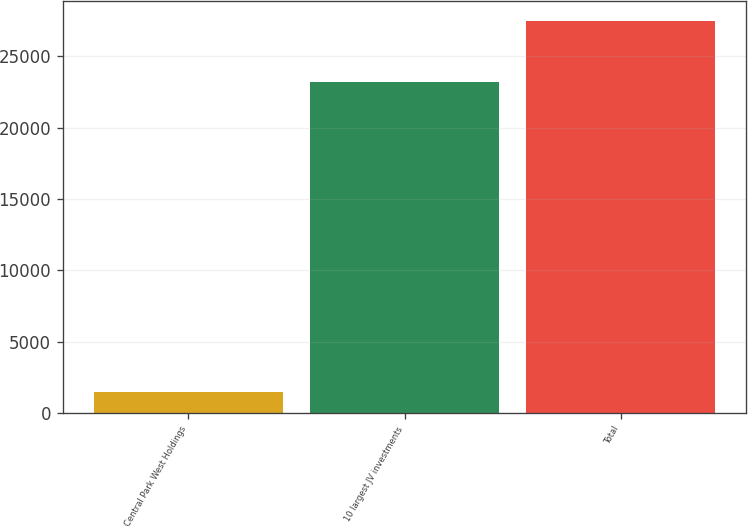Convert chart to OTSL. <chart><loc_0><loc_0><loc_500><loc_500><bar_chart><fcel>Central Park West Holdings<fcel>10 largest JV investments<fcel>Total<nl><fcel>1500<fcel>23232<fcel>27496<nl></chart> 